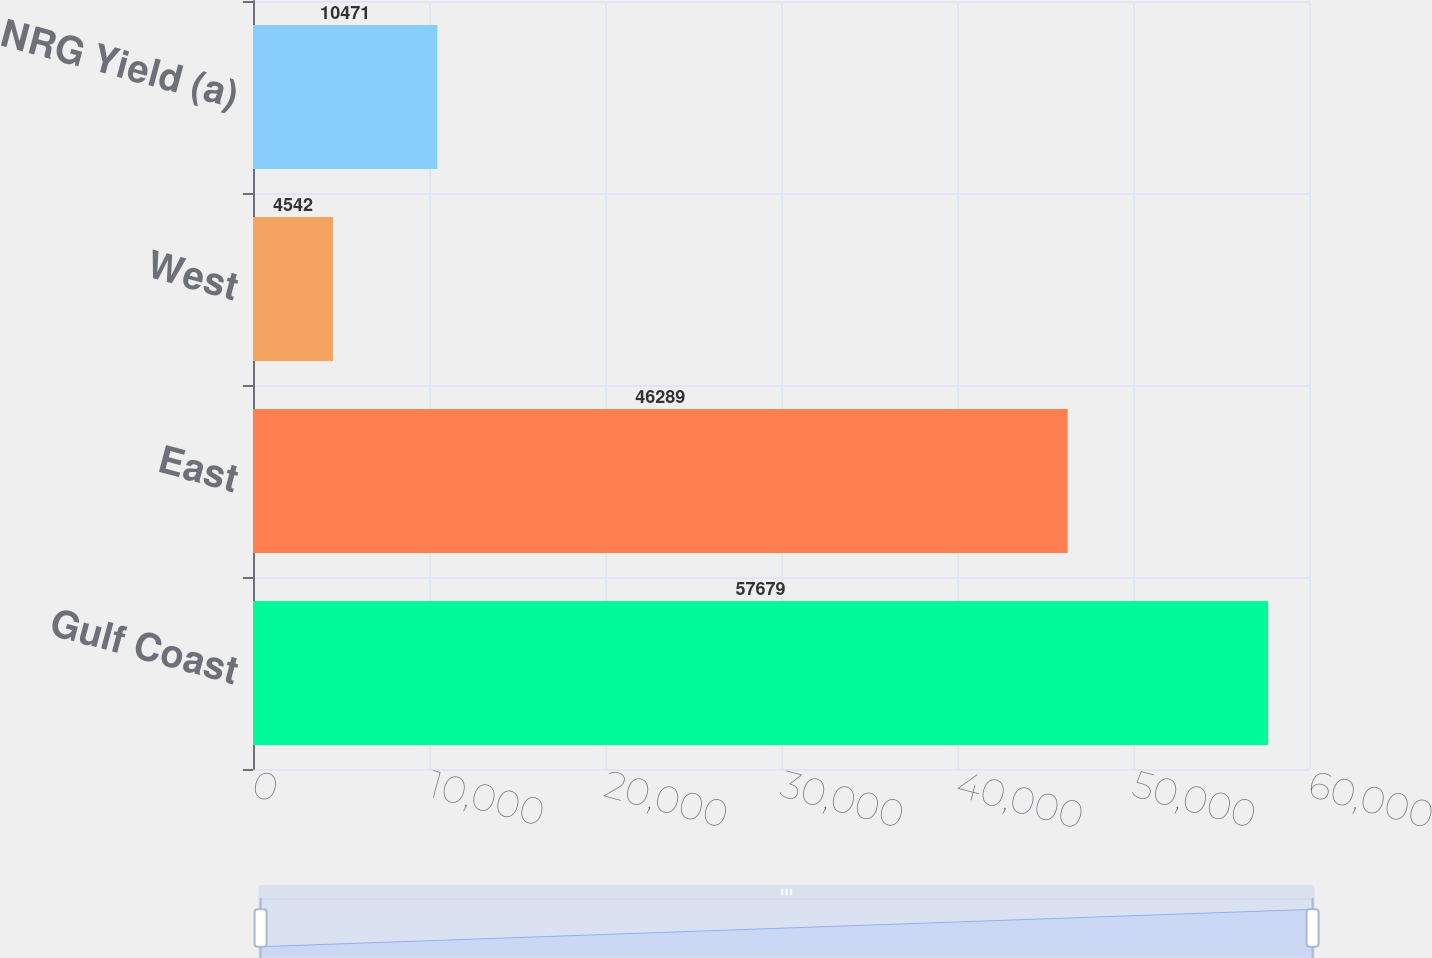Convert chart to OTSL. <chart><loc_0><loc_0><loc_500><loc_500><bar_chart><fcel>Gulf Coast<fcel>East<fcel>West<fcel>NRG Yield (a)<nl><fcel>57679<fcel>46289<fcel>4542<fcel>10471<nl></chart> 